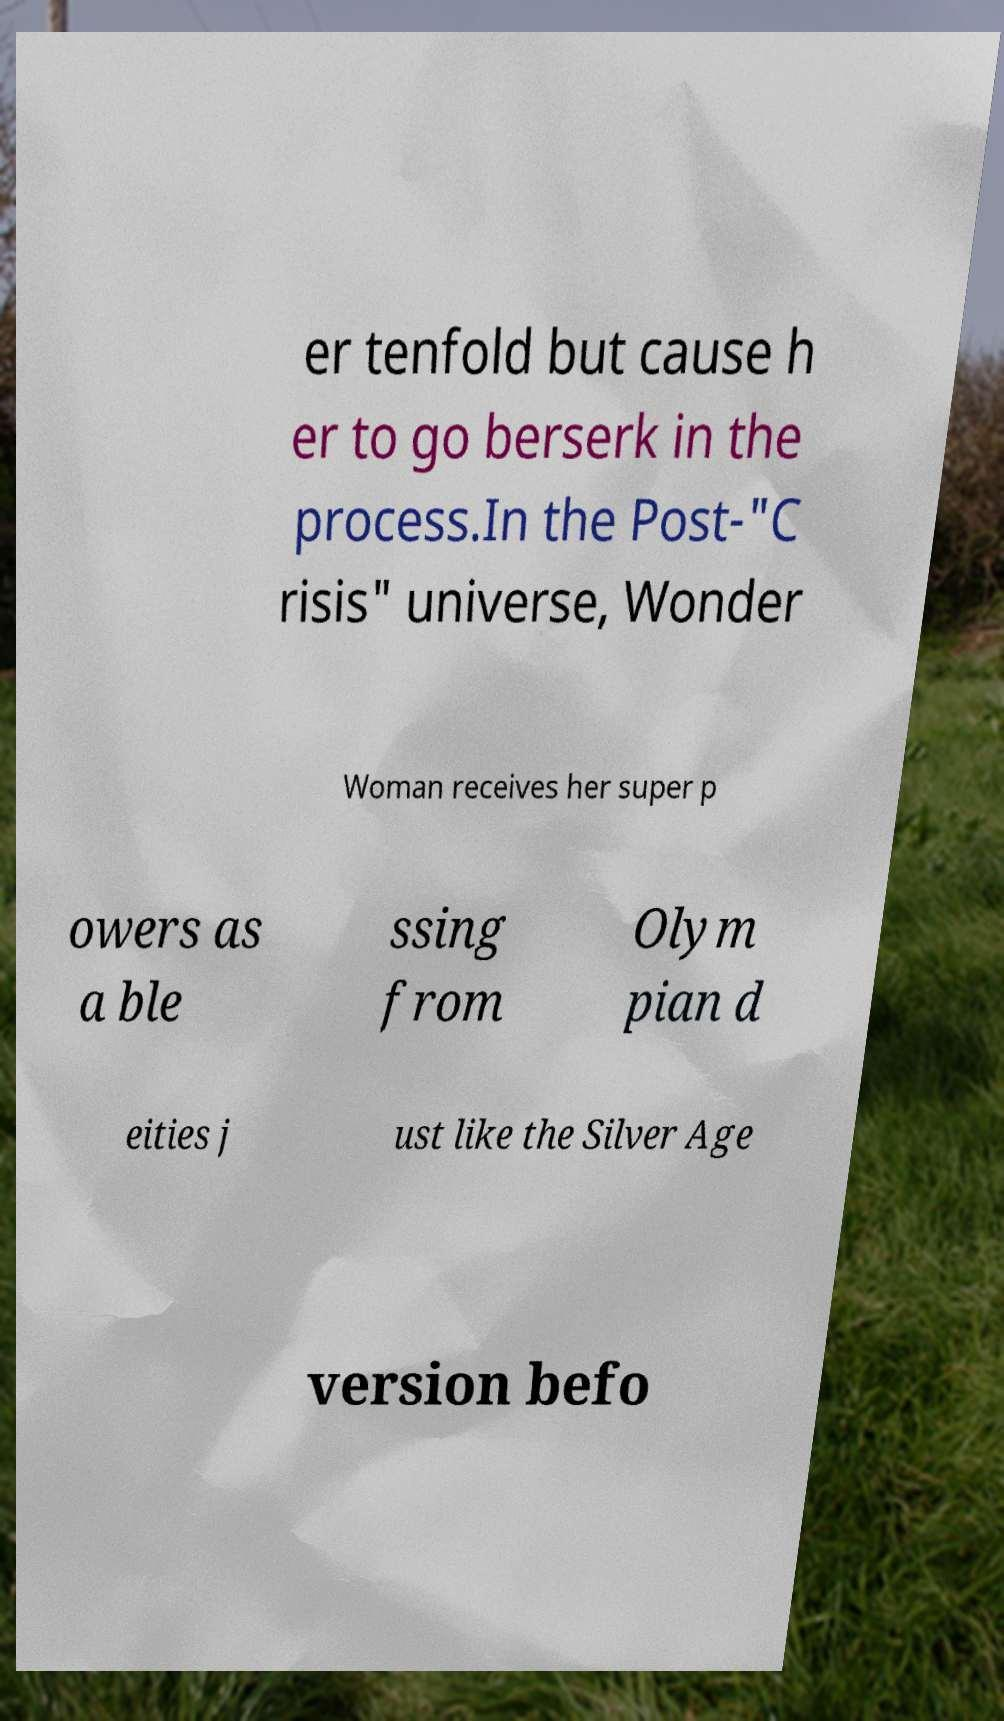There's text embedded in this image that I need extracted. Can you transcribe it verbatim? er tenfold but cause h er to go berserk in the process.In the Post-"C risis" universe, Wonder Woman receives her super p owers as a ble ssing from Olym pian d eities j ust like the Silver Age version befo 